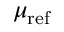Convert formula to latex. <formula><loc_0><loc_0><loc_500><loc_500>\mu _ { r e f }</formula> 